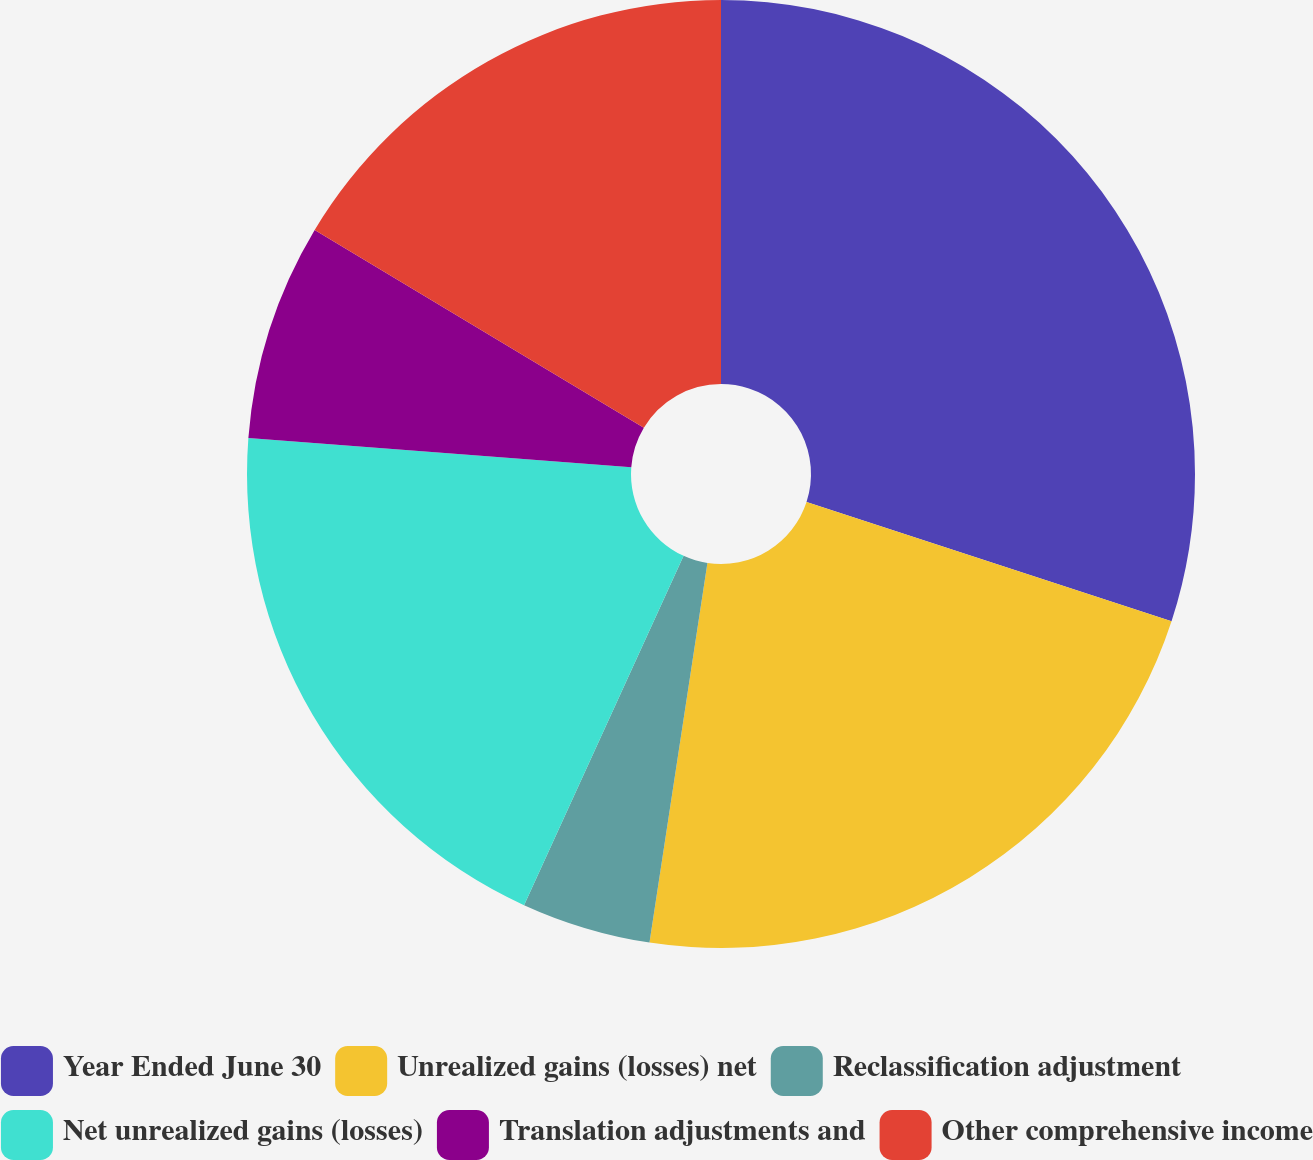Convert chart to OTSL. <chart><loc_0><loc_0><loc_500><loc_500><pie_chart><fcel>Year Ended June 30<fcel>Unrealized gains (losses) net<fcel>Reclassification adjustment<fcel>Net unrealized gains (losses)<fcel>Translation adjustments and<fcel>Other comprehensive income<nl><fcel>30.03%<fcel>22.38%<fcel>4.41%<fcel>19.39%<fcel>7.4%<fcel>16.39%<nl></chart> 